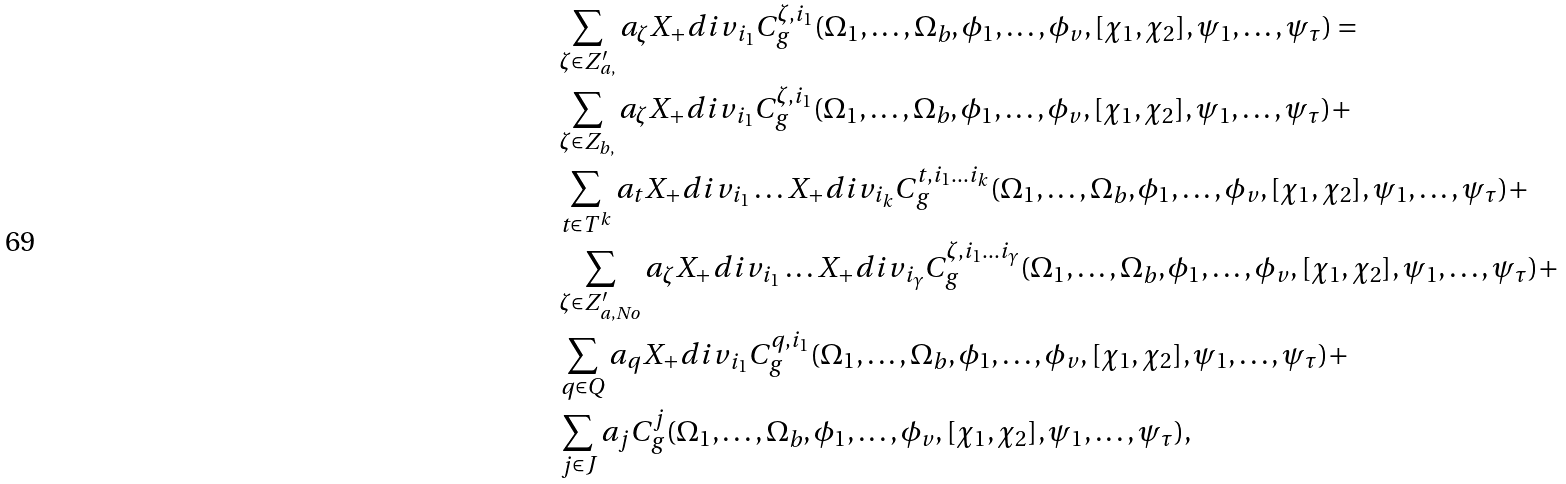Convert formula to latex. <formula><loc_0><loc_0><loc_500><loc_500>& \sum _ { \zeta \in Z ^ { \prime } _ { a , } } a _ { \zeta } X _ { + } d i v _ { i _ { 1 } } C ^ { \zeta , i _ { 1 } } _ { g } ( \Omega _ { 1 } , \dots , \Omega _ { b } , \phi _ { 1 } , \dots , \phi _ { v } , [ \chi _ { 1 } , \chi _ { 2 } ] , \psi _ { 1 } , \dots , \psi _ { \tau } ) = \\ & \sum _ { \zeta \in Z _ { b , } } a _ { \zeta } X _ { + } d i v _ { i _ { 1 } } C ^ { \zeta , i _ { 1 } } _ { g } ( \Omega _ { 1 } , \dots , \Omega _ { b } , \phi _ { 1 } , \dots , \phi _ { v } , [ \chi _ { 1 } , \chi _ { 2 } ] , \psi _ { 1 } , \dots , \psi _ { \tau } ) + \\ & \sum _ { t \in T ^ { k } } a _ { t } X _ { + } d i v _ { i _ { 1 } } \dots X _ { + } d i v _ { i _ { k } } C ^ { t , i _ { 1 } \dots i _ { k } } _ { g } ( \Omega _ { 1 } , \dots , \Omega _ { b } , \phi _ { 1 } , \dots , \phi _ { v } , [ \chi _ { 1 } , \chi _ { 2 } ] , \psi _ { 1 } , \dots , \psi _ { \tau } ) + \\ & \sum _ { \zeta \in Z ^ { \prime } _ { a , N o } } a _ { \zeta } X _ { + } d i v _ { i _ { 1 } } \dots X _ { + } d i v _ { i _ { \gamma } } C ^ { \zeta , i _ { 1 } \dots i _ { \gamma } } _ { g } ( \Omega _ { 1 } , \dots , \Omega _ { b } , \phi _ { 1 } , \dots , \phi _ { v } , [ \chi _ { 1 } , \chi _ { 2 } ] , \psi _ { 1 } , \dots , \psi _ { \tau } ) + \\ & \sum _ { q \in Q } a _ { q } X _ { + } d i v _ { i _ { 1 } } C ^ { q , i _ { 1 } } _ { g } ( \Omega _ { 1 } , \dots , \Omega _ { b } , \phi _ { 1 } , \dots , \phi _ { v } , [ \chi _ { 1 } , \chi _ { 2 } ] , \psi _ { 1 } , \dots , \psi _ { \tau } ) + \\ & \sum _ { j \in J } a _ { j } C ^ { j } _ { g } ( \Omega _ { 1 } , \dots , \Omega _ { b } , \phi _ { 1 } , \dots , \phi _ { v } , [ \chi _ { 1 } , \chi _ { 2 } ] , \psi _ { 1 } , \dots , \psi _ { \tau } ) ,</formula> 